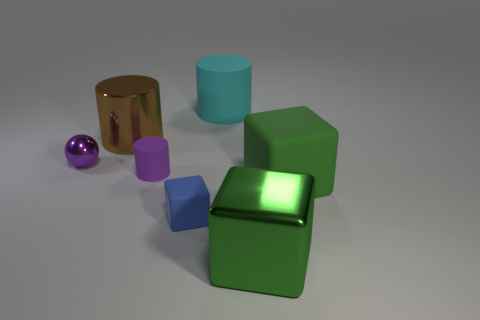What materials do the objects in the image seem to be made of? The image features objects that appear to be made of various materials. The reflective gold and purple objects might be metallic, the matte green and blue objects look like they could be plastic or rubbery, while the semi-transparent aqua object could be glass or a translucent plastic. 